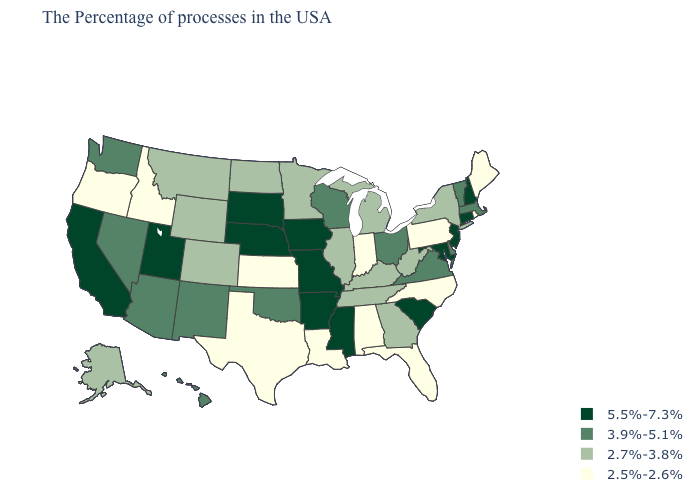Name the states that have a value in the range 3.9%-5.1%?
Concise answer only. Massachusetts, Vermont, Delaware, Virginia, Ohio, Wisconsin, Oklahoma, New Mexico, Arizona, Nevada, Washington, Hawaii. Name the states that have a value in the range 2.7%-3.8%?
Short answer required. New York, West Virginia, Georgia, Michigan, Kentucky, Tennessee, Illinois, Minnesota, North Dakota, Wyoming, Colorado, Montana, Alaska. What is the highest value in the USA?
Keep it brief. 5.5%-7.3%. What is the highest value in the MidWest ?
Write a very short answer. 5.5%-7.3%. Among the states that border Arizona , which have the highest value?
Be succinct. Utah, California. What is the value of Texas?
Give a very brief answer. 2.5%-2.6%. Which states hav the highest value in the West?
Quick response, please. Utah, California. What is the highest value in the USA?
Write a very short answer. 5.5%-7.3%. Name the states that have a value in the range 3.9%-5.1%?
Write a very short answer. Massachusetts, Vermont, Delaware, Virginia, Ohio, Wisconsin, Oklahoma, New Mexico, Arizona, Nevada, Washington, Hawaii. What is the value of Arizona?
Concise answer only. 3.9%-5.1%. Among the states that border Colorado , which have the lowest value?
Answer briefly. Kansas. Which states have the lowest value in the Northeast?
Answer briefly. Maine, Rhode Island, Pennsylvania. What is the value of Kansas?
Keep it brief. 2.5%-2.6%. What is the value of Minnesota?
Write a very short answer. 2.7%-3.8%. Which states have the lowest value in the USA?
Concise answer only. Maine, Rhode Island, Pennsylvania, North Carolina, Florida, Indiana, Alabama, Louisiana, Kansas, Texas, Idaho, Oregon. 